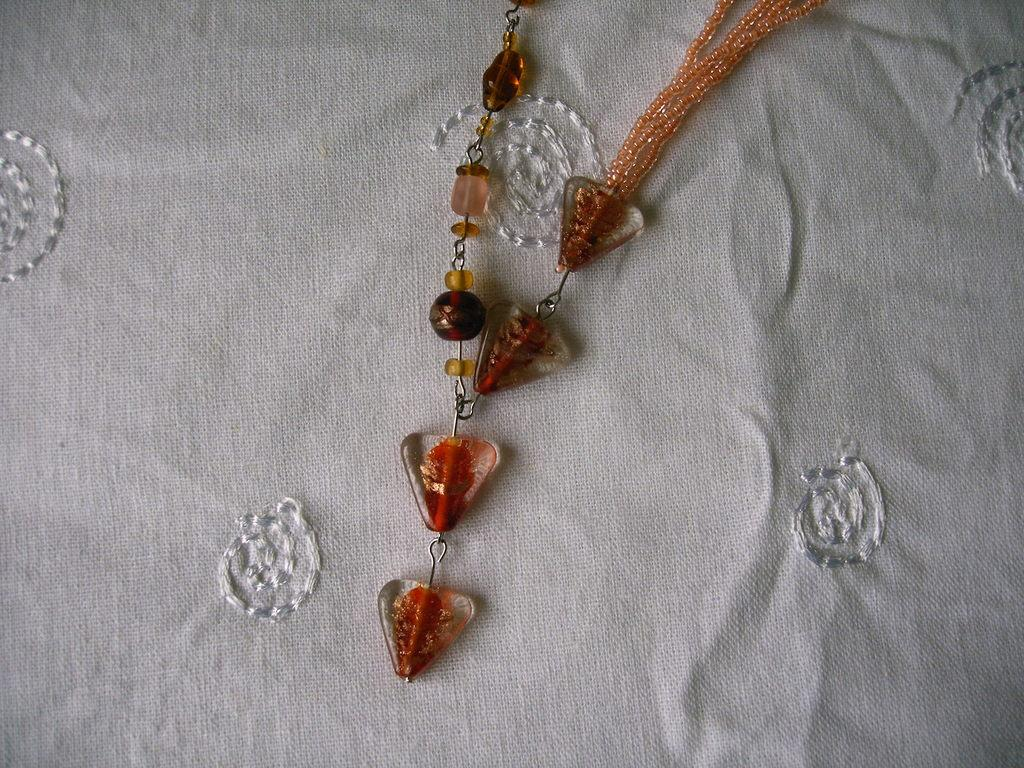What is the primary color of the cloth in the image? The cloth in the image is white. What is attached to the white cloth? There is a colorful chain on the cloth. What type of grass can be seen growing on the holiday in the image? There is no grass or holiday present in the image; it only features a white cloth with a colorful chain. 